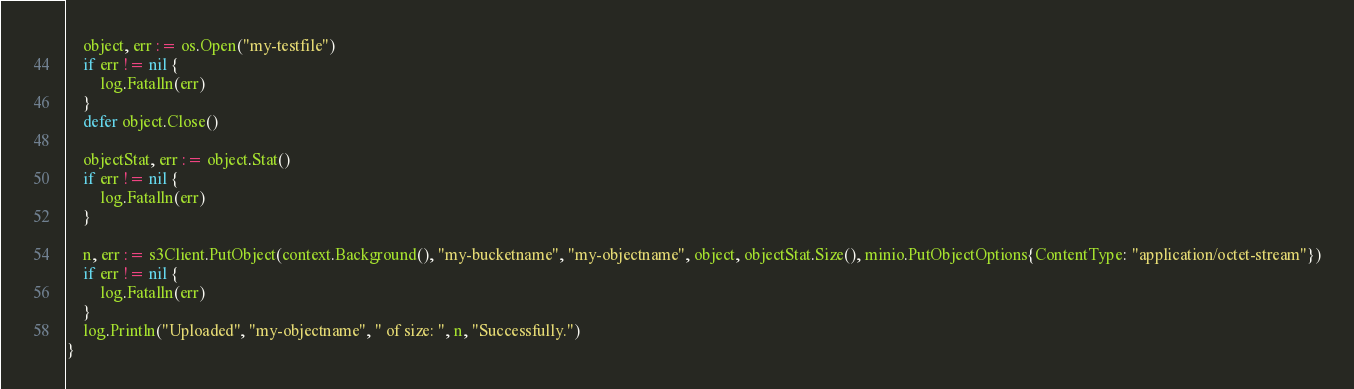Convert code to text. <code><loc_0><loc_0><loc_500><loc_500><_Go_>	object, err := os.Open("my-testfile")
	if err != nil {
		log.Fatalln(err)
	}
	defer object.Close()

	objectStat, err := object.Stat()
	if err != nil {
		log.Fatalln(err)
	}

	n, err := s3Client.PutObject(context.Background(), "my-bucketname", "my-objectname", object, objectStat.Size(), minio.PutObjectOptions{ContentType: "application/octet-stream"})
	if err != nil {
		log.Fatalln(err)
	}
	log.Println("Uploaded", "my-objectname", " of size: ", n, "Successfully.")
}
</code> 